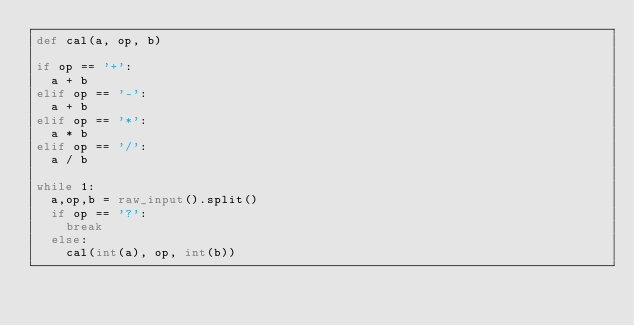<code> <loc_0><loc_0><loc_500><loc_500><_Python_>def cal(a, op, b)

if op == '+':
  a + b
elif op == '-':
  a + b
elif op == '*':
  a * b
elif op == '/':
  a / b

while 1:
  a,op,b = raw_input().split()
  if op == '?':
    break
  else:
    cal(int(a), op, int(b))</code> 